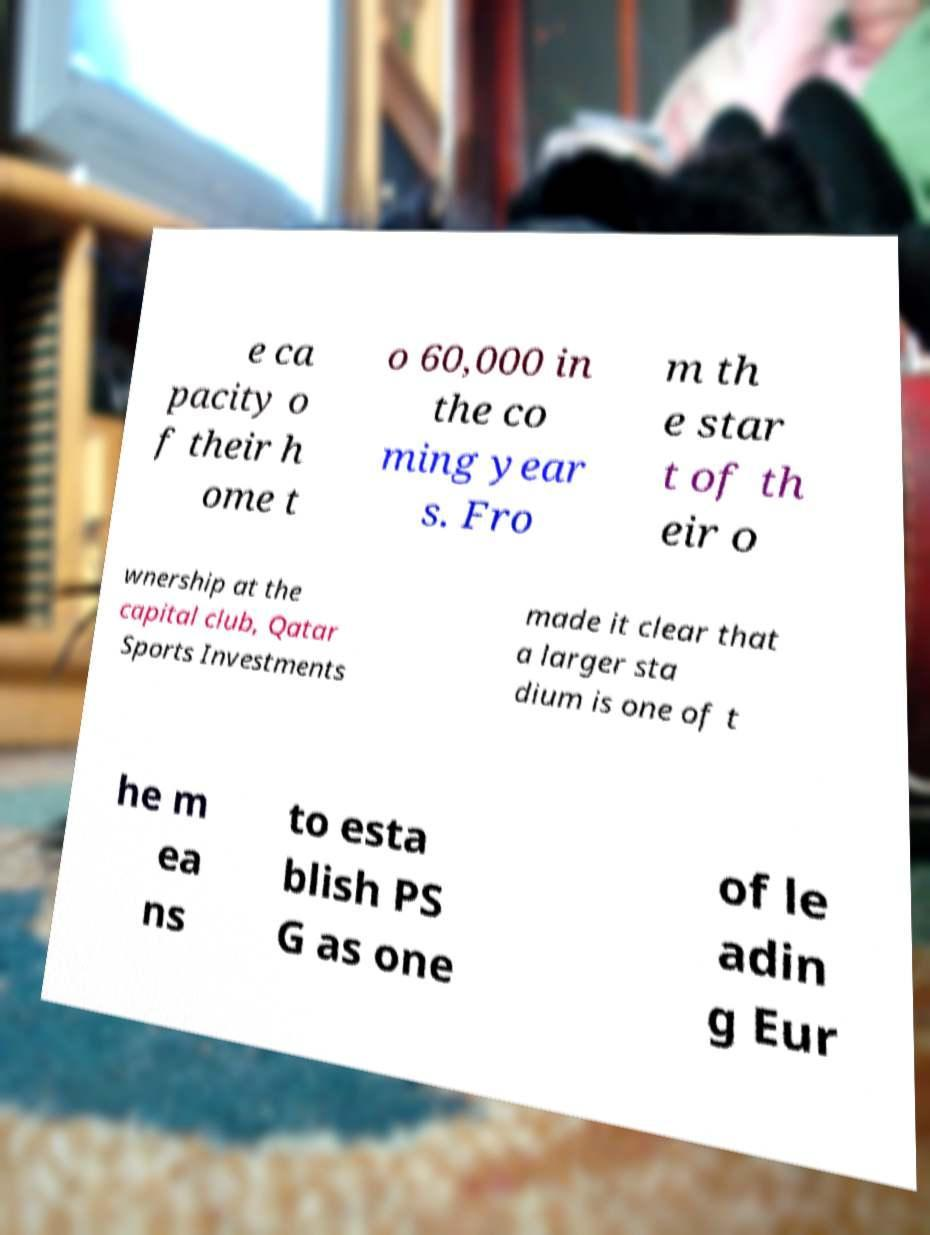There's text embedded in this image that I need extracted. Can you transcribe it verbatim? e ca pacity o f their h ome t o 60,000 in the co ming year s. Fro m th e star t of th eir o wnership at the capital club, Qatar Sports Investments made it clear that a larger sta dium is one of t he m ea ns to esta blish PS G as one of le adin g Eur 